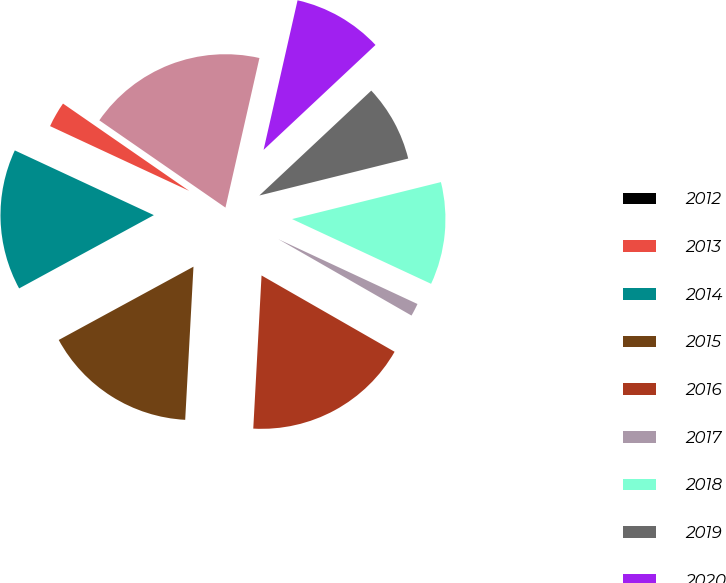Convert chart. <chart><loc_0><loc_0><loc_500><loc_500><pie_chart><fcel>2012<fcel>2013<fcel>2014<fcel>2015<fcel>2016<fcel>2017<fcel>2018<fcel>2019<fcel>2020<fcel>2021<nl><fcel>0.0%<fcel>2.7%<fcel>14.86%<fcel>16.21%<fcel>17.57%<fcel>1.35%<fcel>10.81%<fcel>8.11%<fcel>9.46%<fcel>18.92%<nl></chart> 